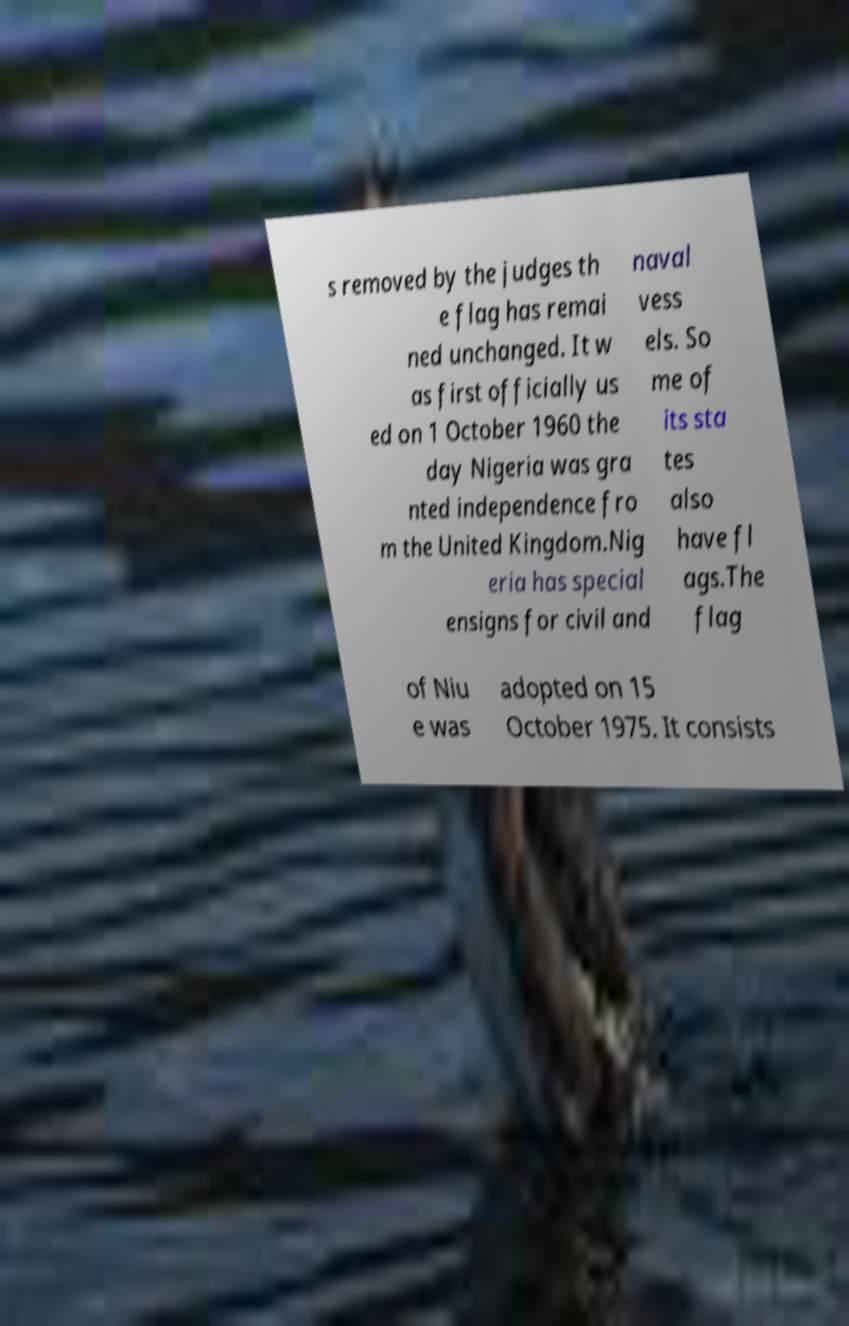There's text embedded in this image that I need extracted. Can you transcribe it verbatim? s removed by the judges th e flag has remai ned unchanged. It w as first officially us ed on 1 October 1960 the day Nigeria was gra nted independence fro m the United Kingdom.Nig eria has special ensigns for civil and naval vess els. So me of its sta tes also have fl ags.The flag of Niu e was adopted on 15 October 1975. It consists 